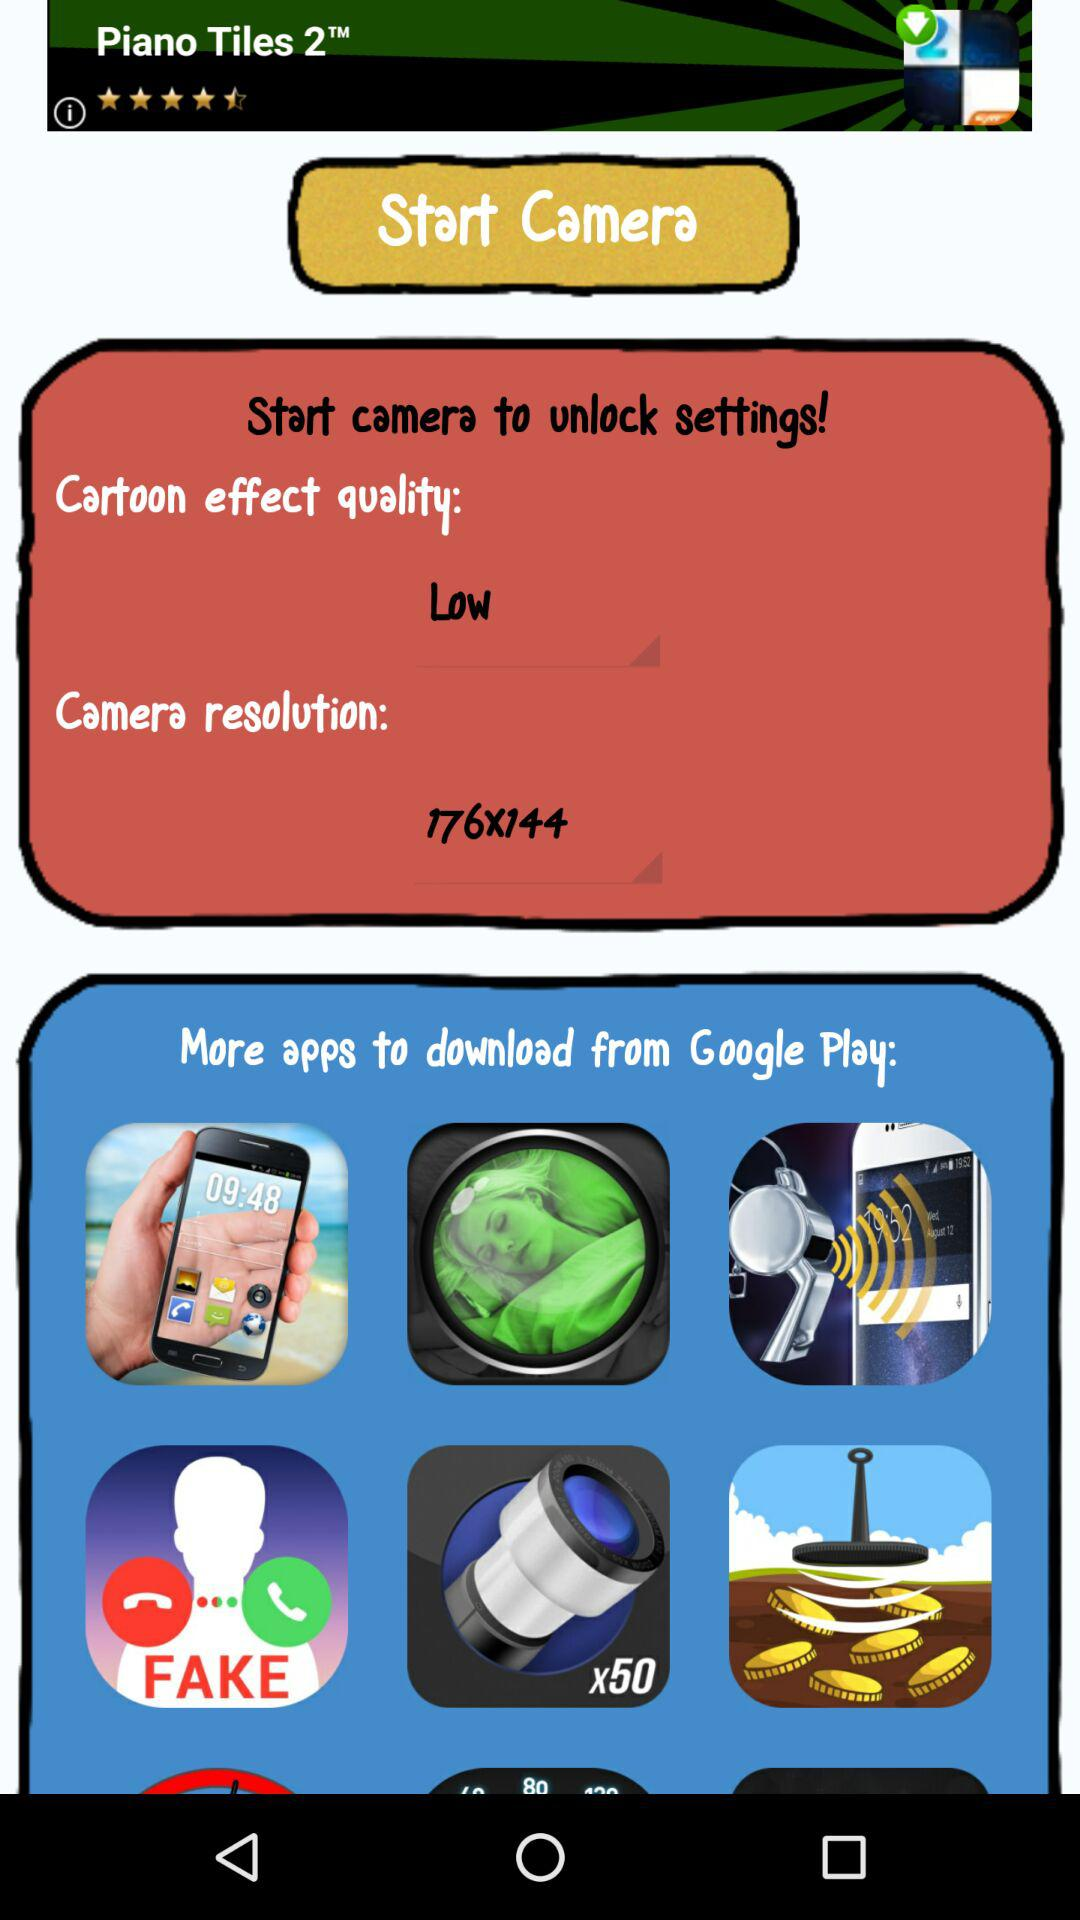What is the "Cartoon effect quality"? The "Cartoon effect quality" is low. 